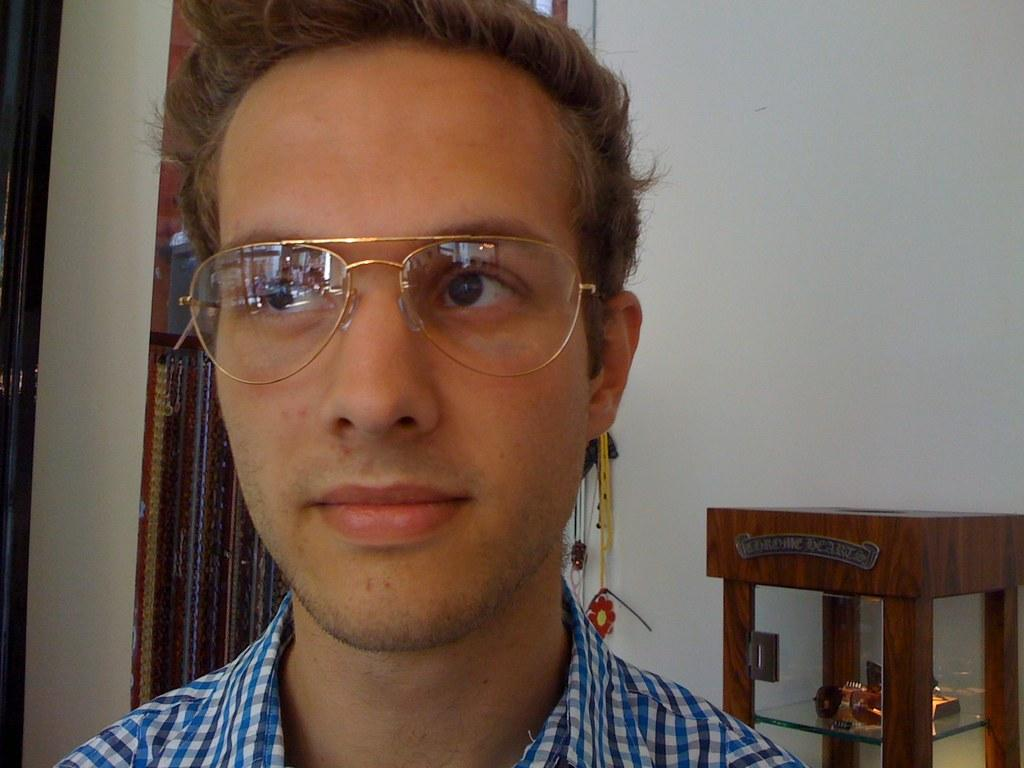What can be seen in the image? There is a person in the image. Can you describe the person's appearance? The person is wearing glasses. What is the person doing in the image? The person is staring at something. What type of object can be seen in the background of the image? There is a wooden object in the background of the image. Reasoning: Let' Let's think step by step in order to produce the conversation. We start by identifying the main subject in the image, which is the person. Then, we describe the person's appearance by mentioning the glasses they are wearing. Next, we focus on the person's action, which is staring at something. Finally, we mention the wooden object in the background to provide more context about the setting. Absurd Question/Answer: What type of kite is the person flying in the image? There is no kite present in the image; the person is simply staring at something. How does the person's attention affect the rotation of the earth in the image? The rotation of the earth is not affected by the person's attention in the image, as the image does not depict the earth or any celestial bodies. 